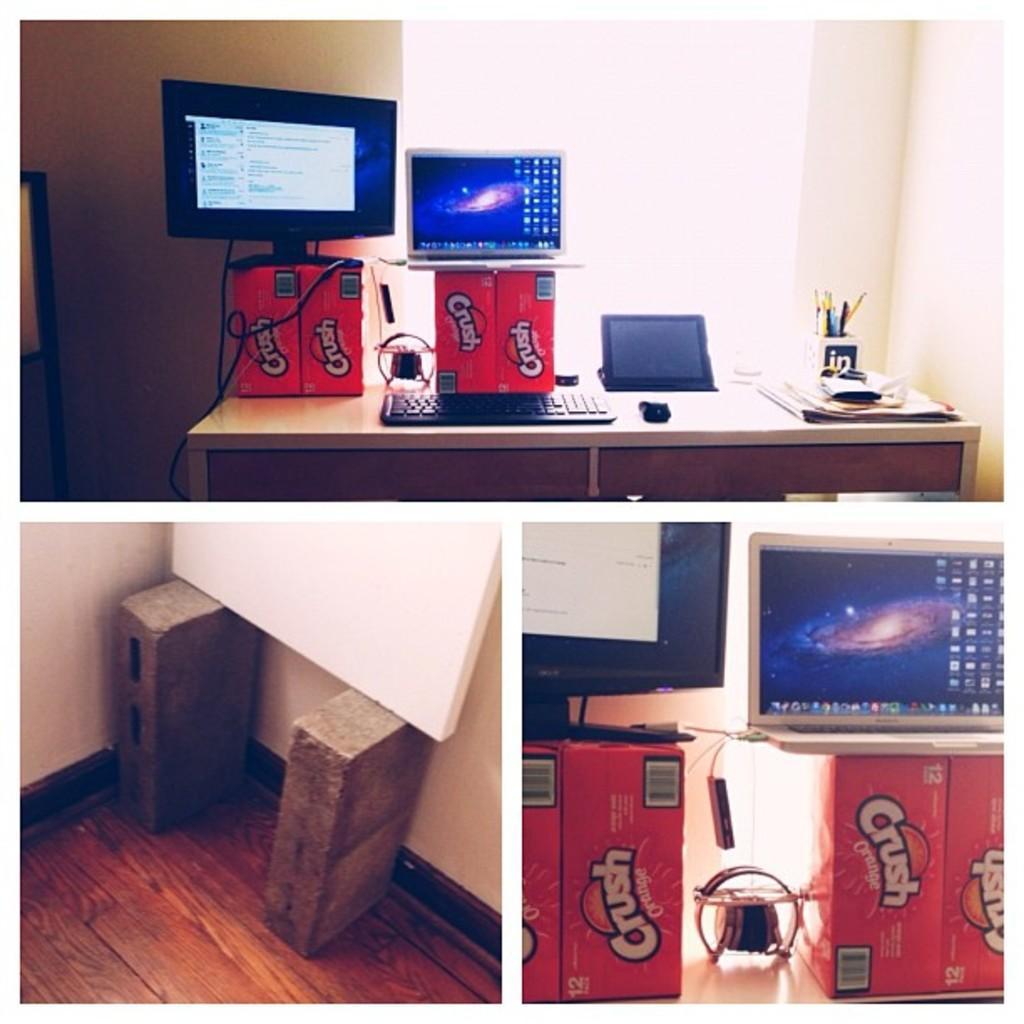Describe this image in one or two sentences. In this image there is a collage of three pictures. There is a table on which there is a keyboard,mouse,ipad, papers and a pen stand. There are two boxes on which there are desktop and a laptop. There are two bricks on the wooden floor. On the bricks there is a whiteboard. 